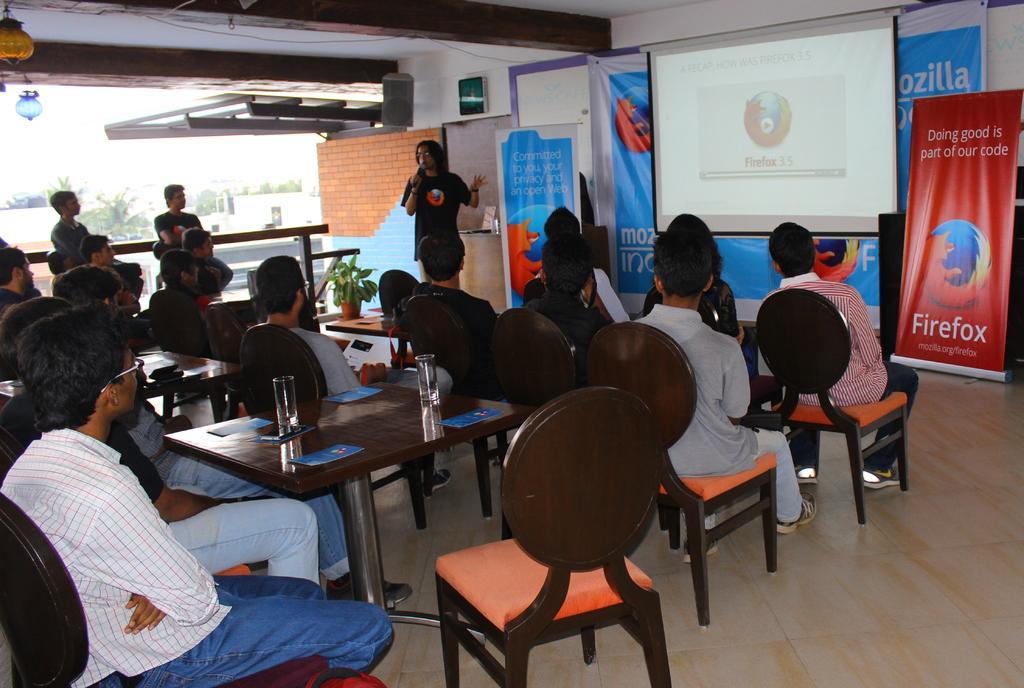Please provide a concise description of this image. This picture is clicked inside a room. There are people sitting on chairs at the table. On the table there are glasses and brochures. There is a man standing and holding microphone and addressing the crowd. In front of him there is a table and on it there is a house plant. There is a projector board hanging to the wall. In the room there are boards and banners. There are lamps hanging to the ceiling. On the other side of the room there is railing. In the background there is sky. 